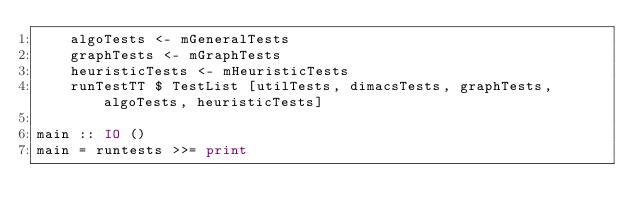<code> <loc_0><loc_0><loc_500><loc_500><_Haskell_>    algoTests <- mGeneralTests
    graphTests <- mGraphTests
    heuristicTests <- mHeuristicTests
    runTestTT $ TestList [utilTests, dimacsTests, graphTests, algoTests, heuristicTests]

main :: IO ()
main = runtests >>= print
</code> 